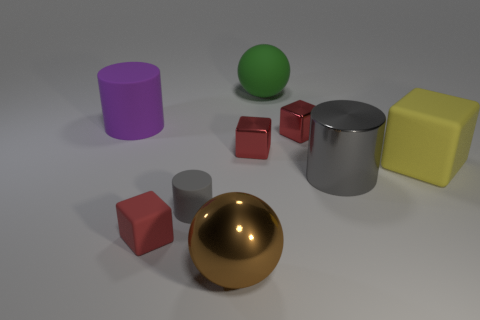Is the color of the tiny cylinder the same as the big shiny object that is to the right of the large green rubber sphere?
Provide a succinct answer. Yes. There is a small thing that is the same color as the metallic cylinder; what is it made of?
Keep it short and to the point. Rubber. The purple cylinder has what size?
Offer a very short reply. Large. There is a matte cylinder that is to the right of the red matte thing; how big is it?
Keep it short and to the point. Small. Are there fewer large gray metal objects behind the large green ball than brown things?
Make the answer very short. Yes. Is the color of the small cylinder the same as the large metal cylinder?
Offer a terse response. Yes. Is the number of small gray matte cylinders less than the number of small red metallic things?
Offer a very short reply. Yes. What color is the big shiny thing behind the matte cylinder on the right side of the purple matte thing?
Make the answer very short. Gray. There is a red cube in front of the big cylinder that is in front of the big cylinder that is left of the tiny red rubber thing; what is its material?
Make the answer very short. Rubber. Does the matte cylinder that is in front of the purple matte cylinder have the same size as the metallic sphere?
Keep it short and to the point. No. 